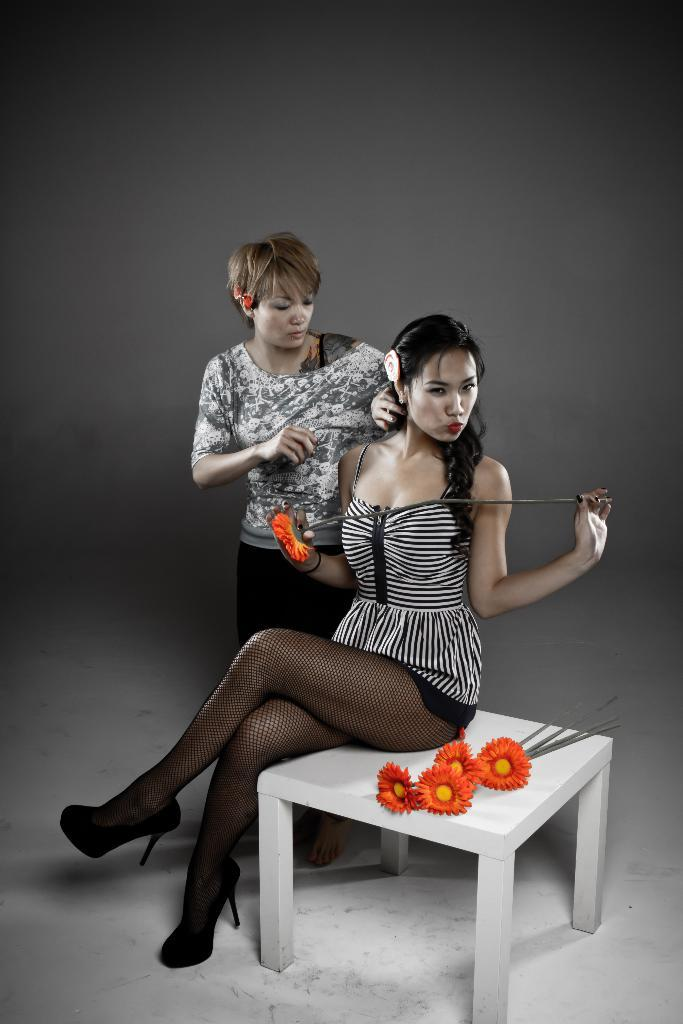How many women are in the picture? There are two women in the picture. What are the positions of the women in the image? One woman is sitting, and the other is standing beside her. What is present on the table in the image? Flowers are placed on the table. What can be seen in the background of the image? There is a wall in the background of the image. What design is the woman wearing on her shirt in the image? There is no information about the design on the woman's shirt in the image. How much attention is the woman receiving in the image? The image does not provide information about the amount of attention the woman is receiving. 